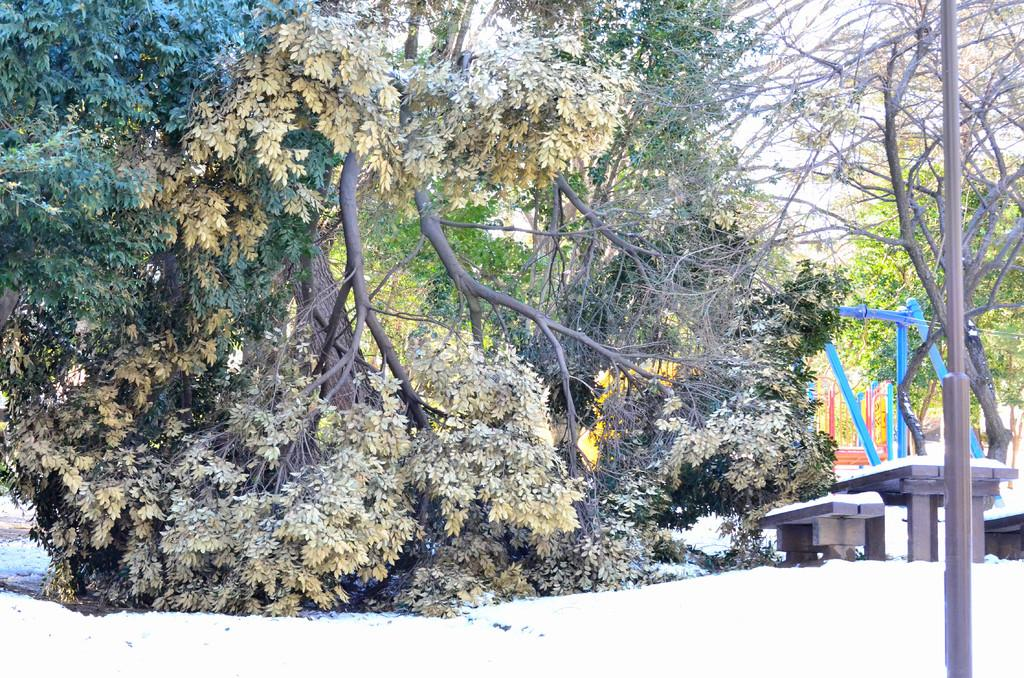What is the main feature of the landscape in the image? There are many trees in the image, and they are on a snow-covered land. Can you describe any structures or objects in the image? There is a pole on the right side of the image, and in the background, there is a table and a bench. What is your grandmother doing while laughing on the stick in the image? There is no grandmother, laughter, or stick present in the image. 